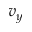<formula> <loc_0><loc_0><loc_500><loc_500>v _ { y }</formula> 